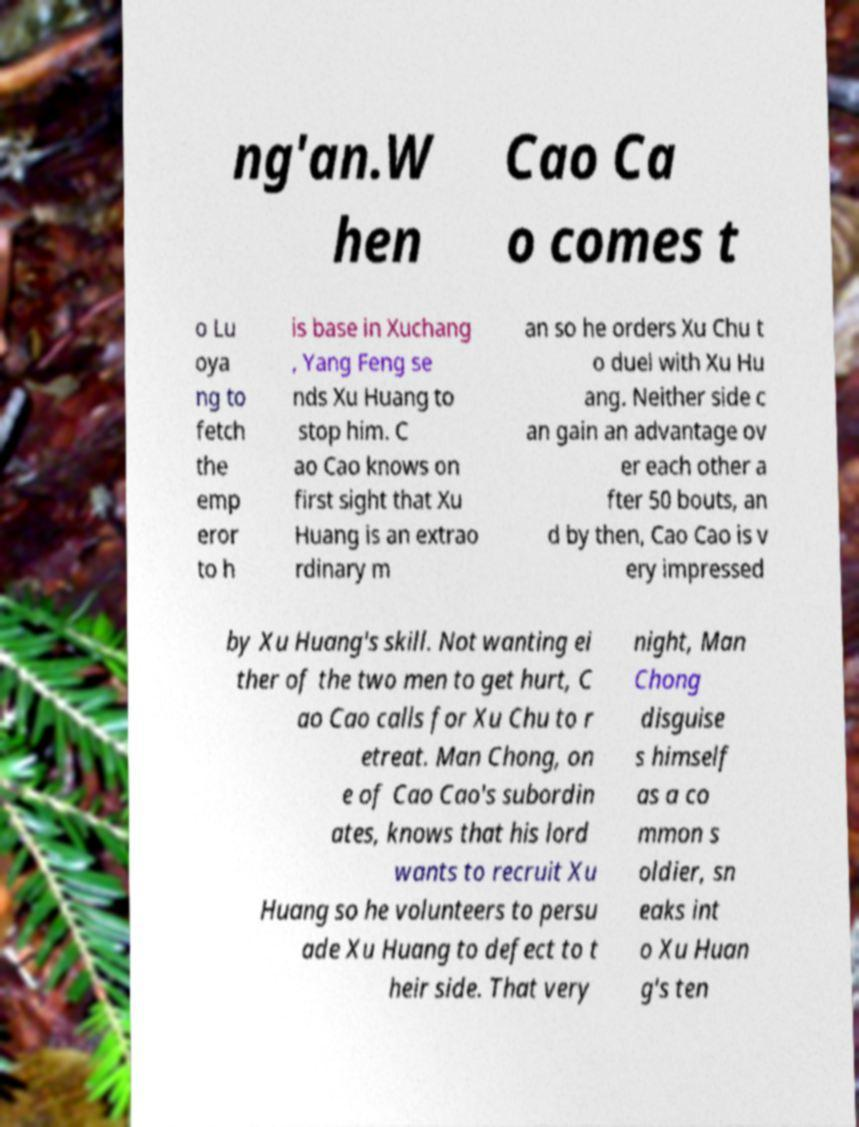Could you assist in decoding the text presented in this image and type it out clearly? ng'an.W hen Cao Ca o comes t o Lu oya ng to fetch the emp eror to h is base in Xuchang , Yang Feng se nds Xu Huang to stop him. C ao Cao knows on first sight that Xu Huang is an extrao rdinary m an so he orders Xu Chu t o duel with Xu Hu ang. Neither side c an gain an advantage ov er each other a fter 50 bouts, an d by then, Cao Cao is v ery impressed by Xu Huang's skill. Not wanting ei ther of the two men to get hurt, C ao Cao calls for Xu Chu to r etreat. Man Chong, on e of Cao Cao's subordin ates, knows that his lord wants to recruit Xu Huang so he volunteers to persu ade Xu Huang to defect to t heir side. That very night, Man Chong disguise s himself as a co mmon s oldier, sn eaks int o Xu Huan g's ten 